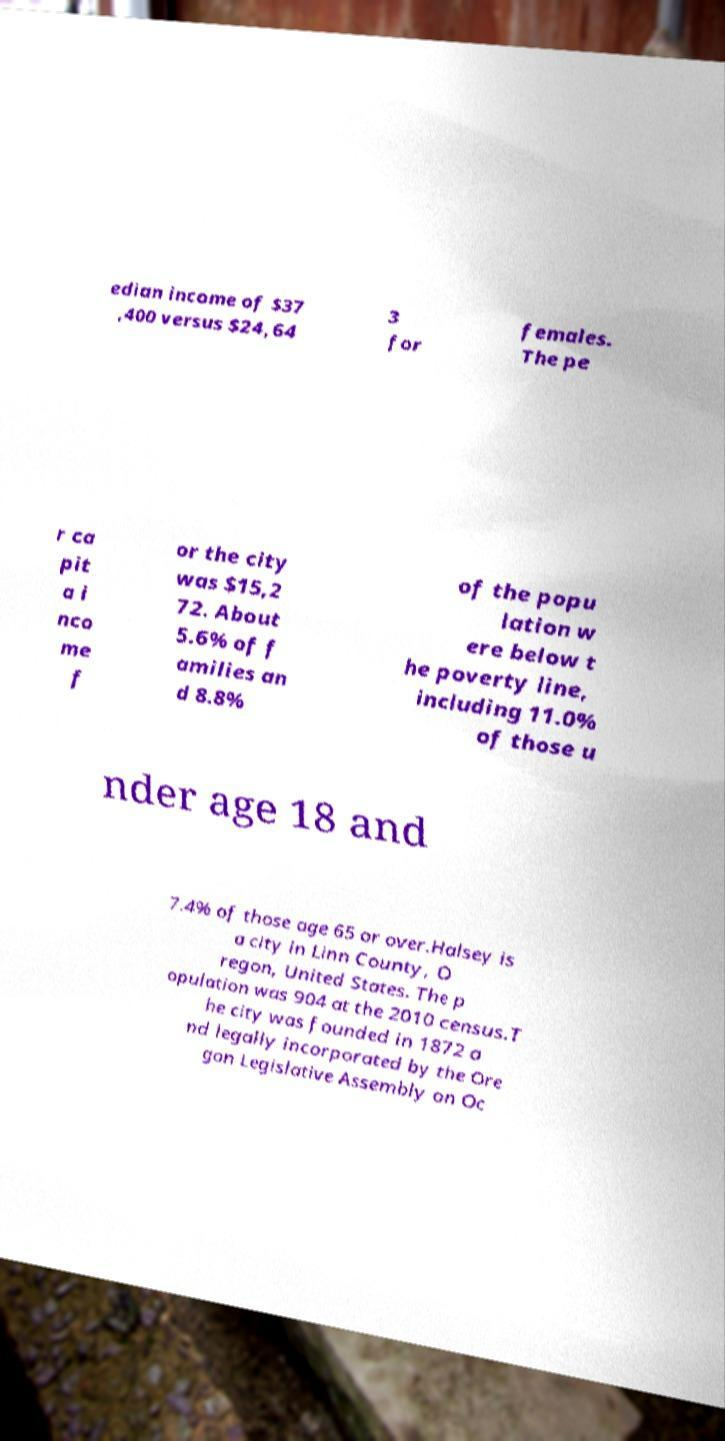Please read and relay the text visible in this image. What does it say? edian income of $37 ,400 versus $24,64 3 for females. The pe r ca pit a i nco me f or the city was $15,2 72. About 5.6% of f amilies an d 8.8% of the popu lation w ere below t he poverty line, including 11.0% of those u nder age 18 and 7.4% of those age 65 or over.Halsey is a city in Linn County, O regon, United States. The p opulation was 904 at the 2010 census.T he city was founded in 1872 a nd legally incorporated by the Ore gon Legislative Assembly on Oc 